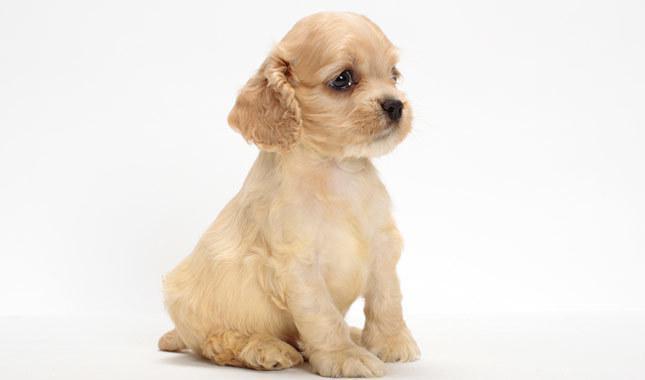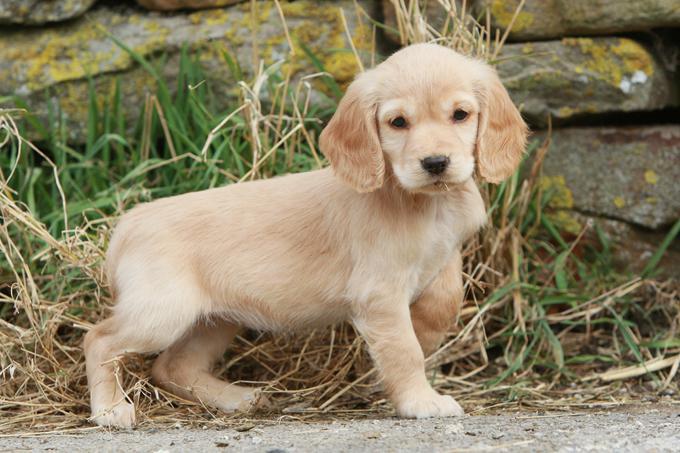The first image is the image on the left, the second image is the image on the right. Evaluate the accuracy of this statement regarding the images: "The right image shows a young puppy.". Is it true? Answer yes or no. Yes. 